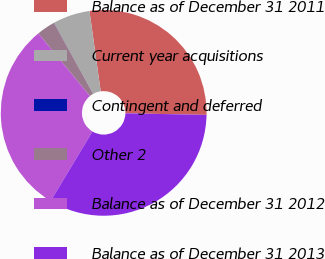Convert chart. <chart><loc_0><loc_0><loc_500><loc_500><pie_chart><fcel>Balance as of December 31 2011<fcel>Current year acquisitions<fcel>Contingent and deferred<fcel>Other 2<fcel>Balance as of December 31 2012<fcel>Balance as of December 31 2013<nl><fcel>27.52%<fcel>5.81%<fcel>0.02%<fcel>2.92%<fcel>30.42%<fcel>33.31%<nl></chart> 